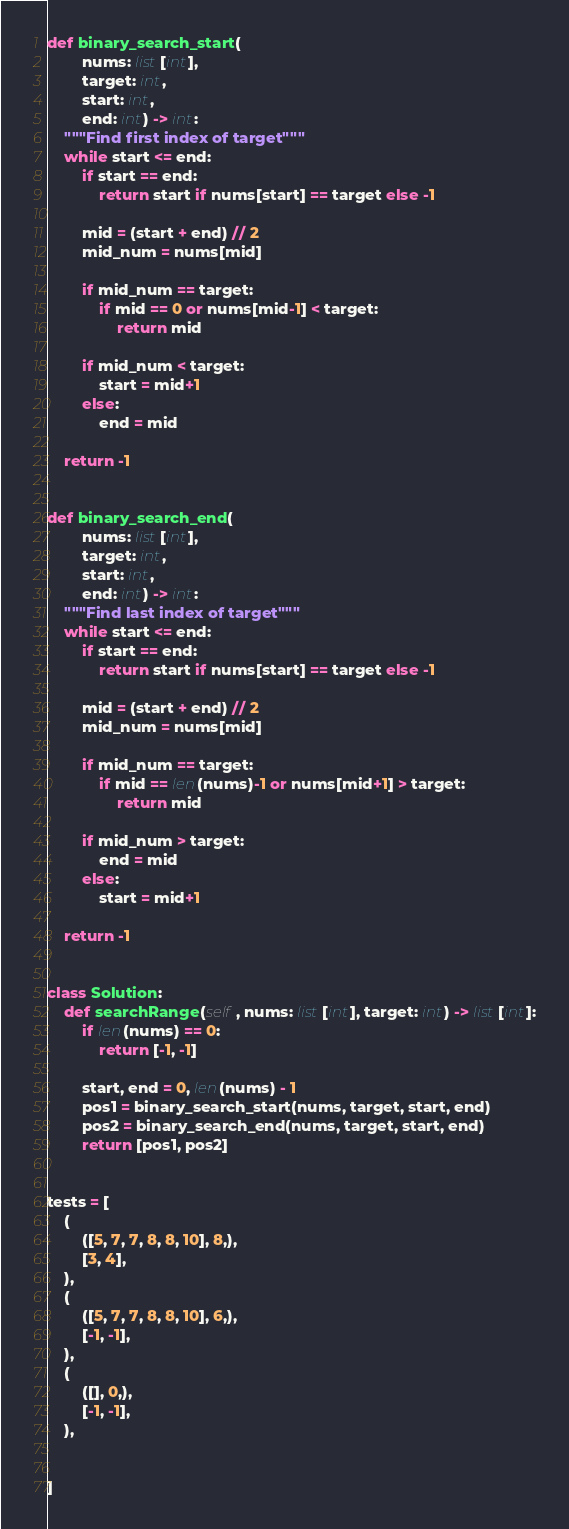Convert code to text. <code><loc_0><loc_0><loc_500><loc_500><_Python_>
def binary_search_start(
        nums: list[int],
        target: int,
        start: int,
        end: int) -> int:
    """Find first index of target"""
    while start <= end:
        if start == end:
            return start if nums[start] == target else -1

        mid = (start + end) // 2
        mid_num = nums[mid]

        if mid_num == target:
            if mid == 0 or nums[mid-1] < target:
                return mid

        if mid_num < target:
            start = mid+1
        else:
            end = mid

    return -1


def binary_search_end(
        nums: list[int],
        target: int,
        start: int,
        end: int) -> int:
    """Find last index of target"""
    while start <= end:
        if start == end:
            return start if nums[start] == target else -1

        mid = (start + end) // 2
        mid_num = nums[mid]

        if mid_num == target:
            if mid == len(nums)-1 or nums[mid+1] > target:
                return mid

        if mid_num > target:
            end = mid
        else:
            start = mid+1

    return -1


class Solution:
    def searchRange(self, nums: list[int], target: int) -> list[int]:
        if len(nums) == 0:
            return [-1, -1]

        start, end = 0, len(nums) - 1
        pos1 = binary_search_start(nums, target, start, end)
        pos2 = binary_search_end(nums, target, start, end)
        return [pos1, pos2]


tests = [
    (
        ([5, 7, 7, 8, 8, 10], 8,),
        [3, 4],
    ),
    (
        ([5, 7, 7, 8, 8, 10], 6,),
        [-1, -1],
    ),
    (
        ([], 0,),
        [-1, -1],
    ),


]
</code> 